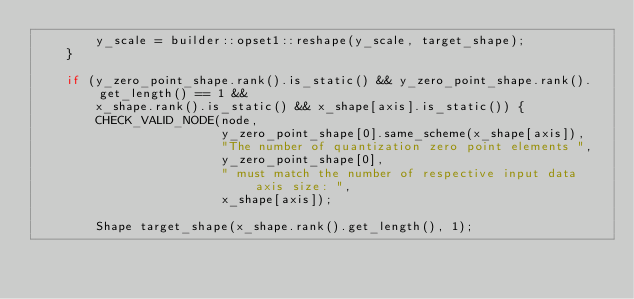Convert code to text. <code><loc_0><loc_0><loc_500><loc_500><_C++_>        y_scale = builder::opset1::reshape(y_scale, target_shape);
    }

    if (y_zero_point_shape.rank().is_static() && y_zero_point_shape.rank().get_length() == 1 &&
        x_shape.rank().is_static() && x_shape[axis].is_static()) {
        CHECK_VALID_NODE(node,
                         y_zero_point_shape[0].same_scheme(x_shape[axis]),
                         "The number of quantization zero point elements ",
                         y_zero_point_shape[0],
                         " must match the number of respective input data axis size: ",
                         x_shape[axis]);

        Shape target_shape(x_shape.rank().get_length(), 1);</code> 